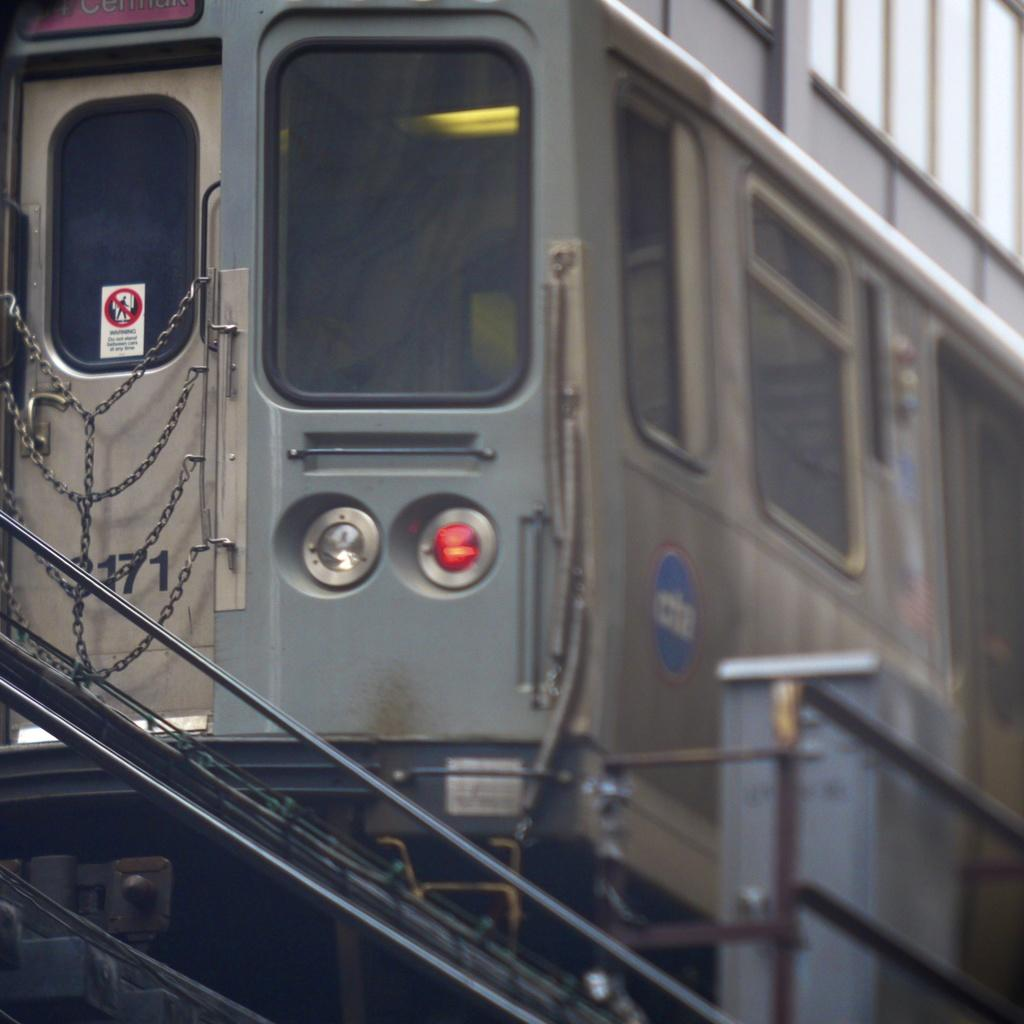What is the main subject in the center of the image? There is a train in the center of the image. What can be seen at the bottom of the image? There are stairs at the bottom of the image. What type of wine is being served at the organization's event in the image? There is no wine or organization event present in the image; it features a train and stairs. 